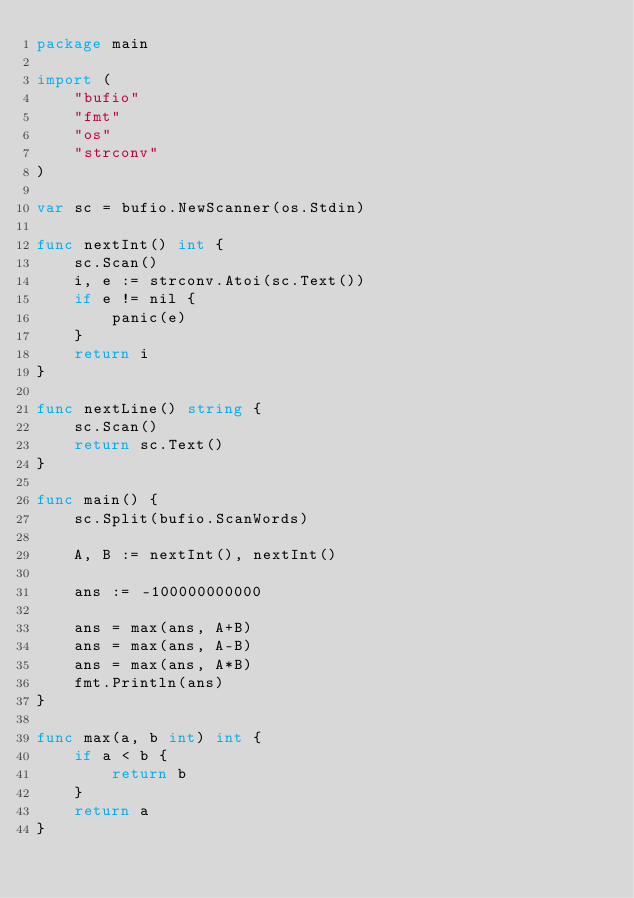Convert code to text. <code><loc_0><loc_0><loc_500><loc_500><_Go_>package main

import (
	"bufio"
	"fmt"
	"os"
	"strconv"
)

var sc = bufio.NewScanner(os.Stdin)

func nextInt() int {
	sc.Scan()
	i, e := strconv.Atoi(sc.Text())
	if e != nil {
		panic(e)
	}
	return i
}

func nextLine() string {
	sc.Scan()
	return sc.Text()
}

func main() {
	sc.Split(bufio.ScanWords)

	A, B := nextInt(), nextInt()

	ans := -100000000000

	ans = max(ans, A+B)
	ans = max(ans, A-B)
	ans = max(ans, A*B)
	fmt.Println(ans)
}

func max(a, b int) int {
	if a < b {
		return b
	}
	return a
}
</code> 